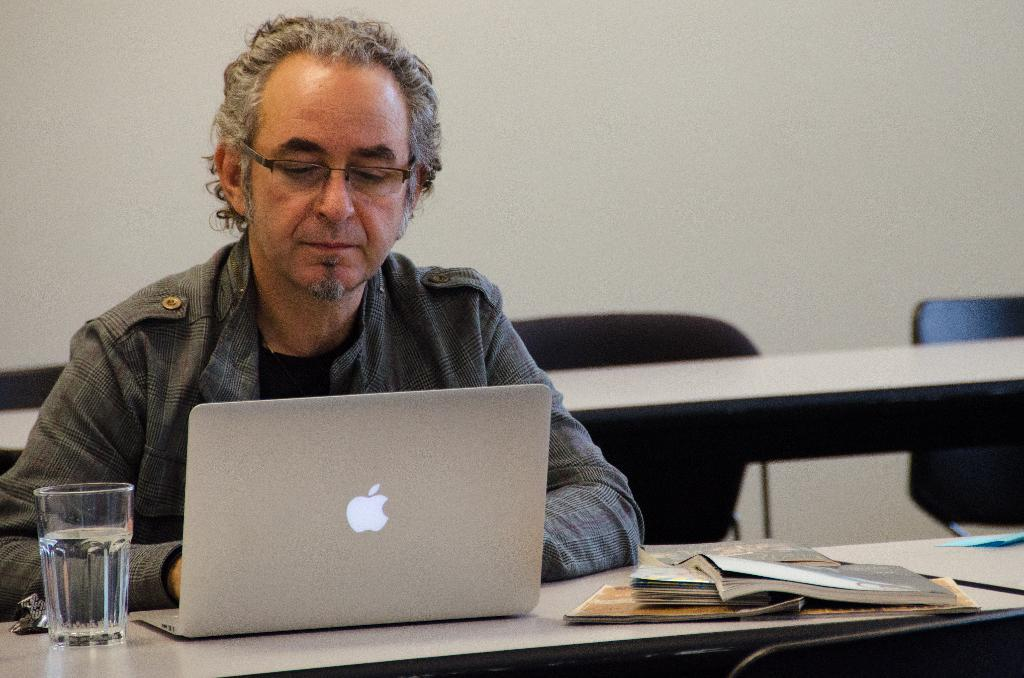What is the man in the image doing? The man is sitting on a chair and working on a laptop. What is on the table in the image? There is a glass and books on the table. What can be seen in the background of the image? There is a table and chairs, as well as a wall, in the background. What type of apparatus is the man using to communicate with the horses in the image? There are no horses or communication apparatus present in the image. 